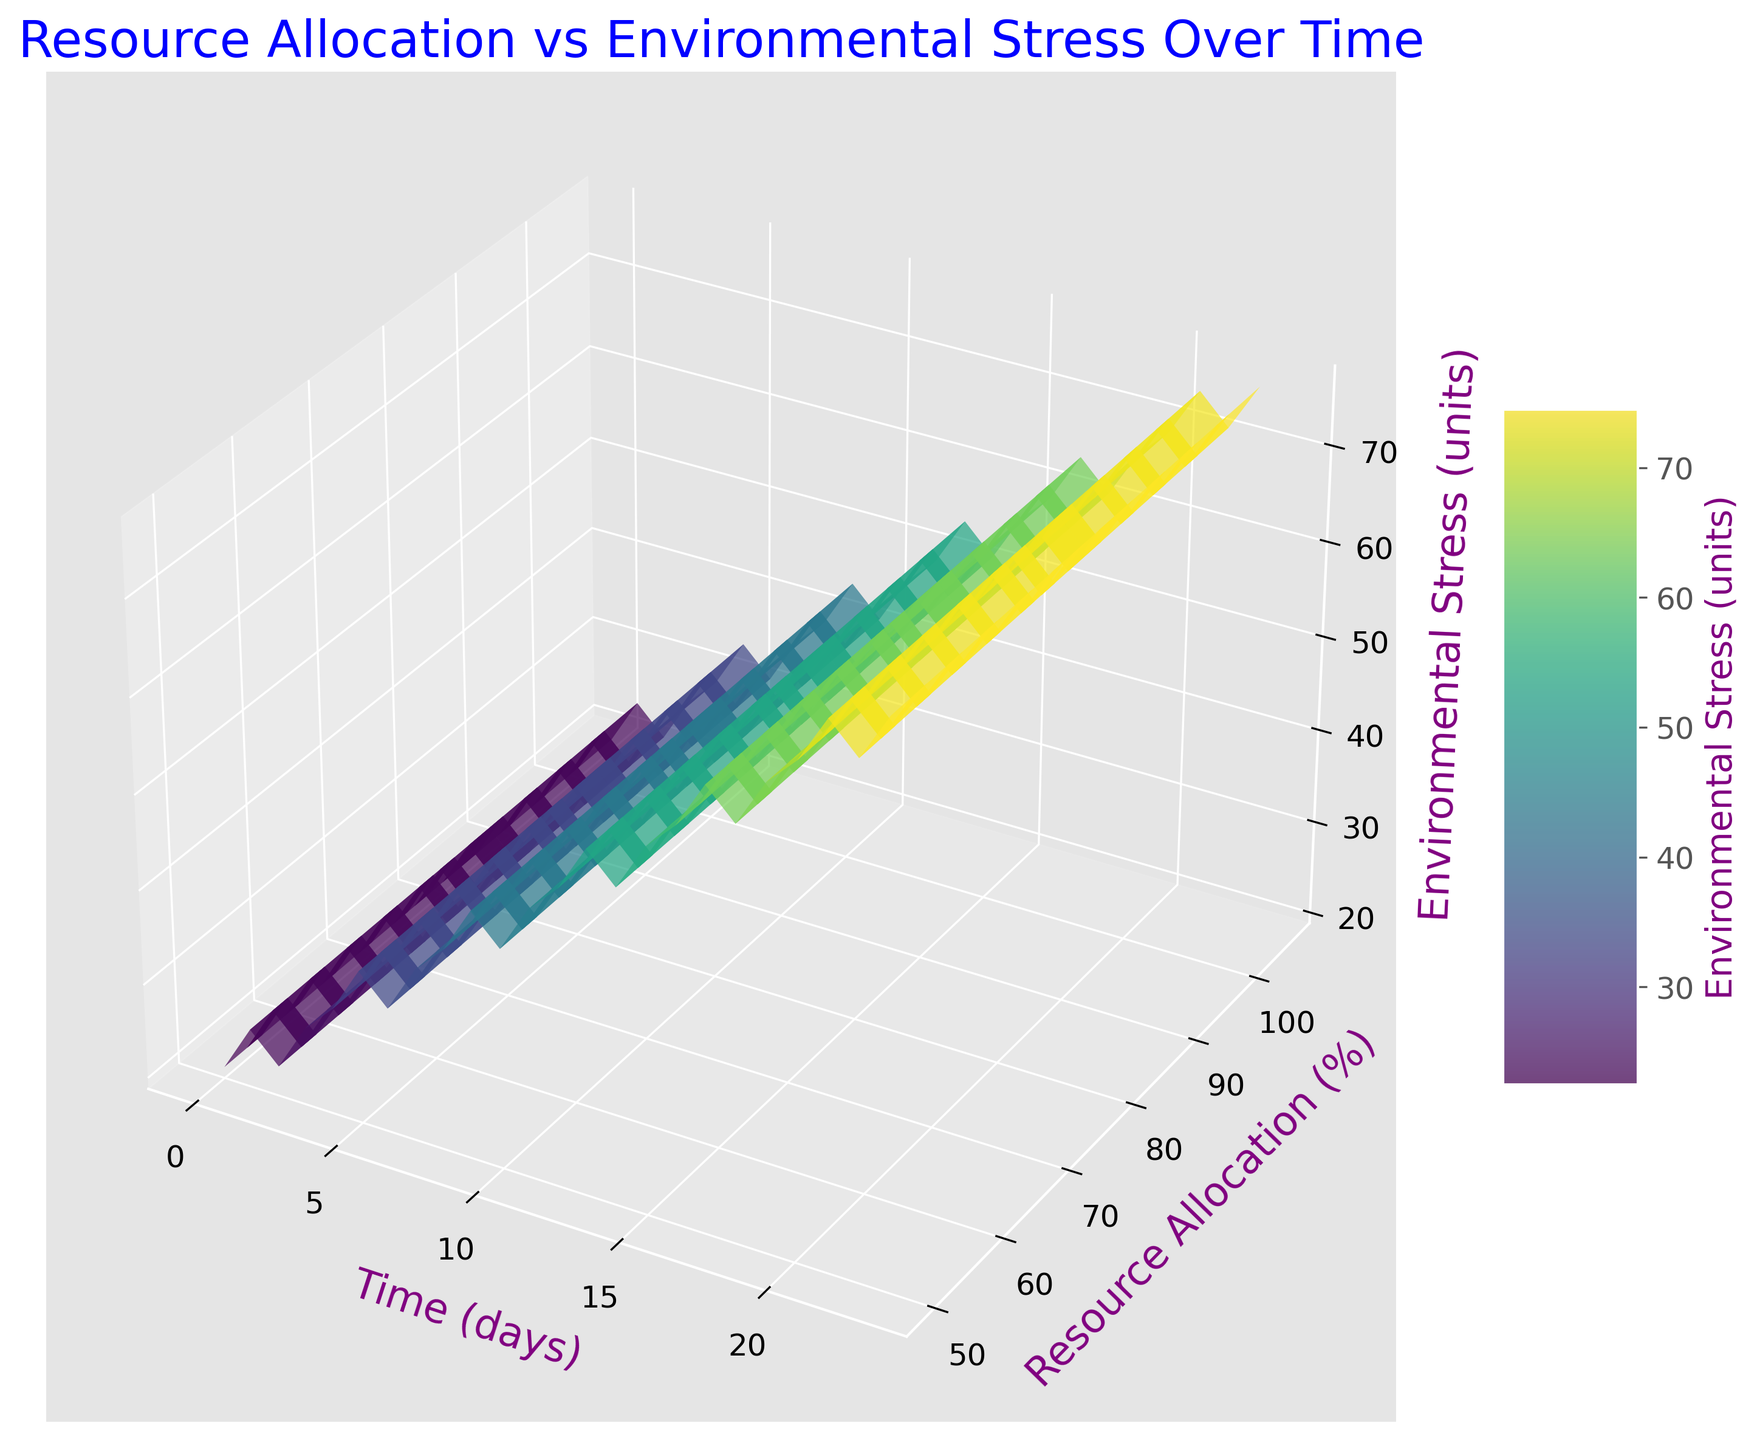What's the trend in resource allocation over time? The plot shows that the resource allocation increases consistently as time progresses.
Answer: Increasing How does environmental stress change as resource allocation increases? As resource allocation increases, environmental stress also increases. This is shown by the upward slope in the 3D surface plot.
Answer: Increases What is the environmental stress level at day 10? By looking at the plot at the corresponding position for day 10 on the time axis, we see that the environmental stress level is around 42 units.
Answer: 42 units Compare the resource allocation at day 5 and day 15. Which day has a higher resource allocation? By examining the plot, at day 5 the resource allocation is 65%, whereas at day 15 it is 85%. Thus, resource allocation is higher at day 15.
Answer: Day 15 What is the average resource allocation from day 0 to day 10? Calculate the sum of resource allocations from day 0 to day 10 (50+55+53+60+58+65+63+70+68+75+73=690), then divide by the number of days (11), which results in 62.73.
Answer: 62.73% Visually, what happens to environmental stress as both time and resource allocation increase? The plot shows that as time and resource allocation both increase, environmental stress increases as well, indicated by a rise in the surface.
Answer: Increases Is there a period where the environmental stress stabilizes or decreases with increasing resource allocation? From the visualization, there are no periods where environmental stress stabilizes or decreases; it uniformly increases.
Answer: No What color indicates the highest environmental stress on the plot, and where is it located? The highest environmental stress is indicated by the darkest shades of green, located near the higher values of both resource allocation and time.
Answer: Darkest green Are there any dips or anomalies in the trend for environmental stress over time? Visually, the trend for environmental stress does not show any dips or anomalies; it is consistently upward.
Answer: No What is the slope of the surface at the initial phase (around days 0 to 5) compared to a later phase (around days 15 to 20)? The surface shows a less steep slope from days 0 to 5, while the slope becomes steeper from days 15 to 20, indicating more rapid increases in environmental stress in the later phase.
Answer: Steeper from days 15 to 20 